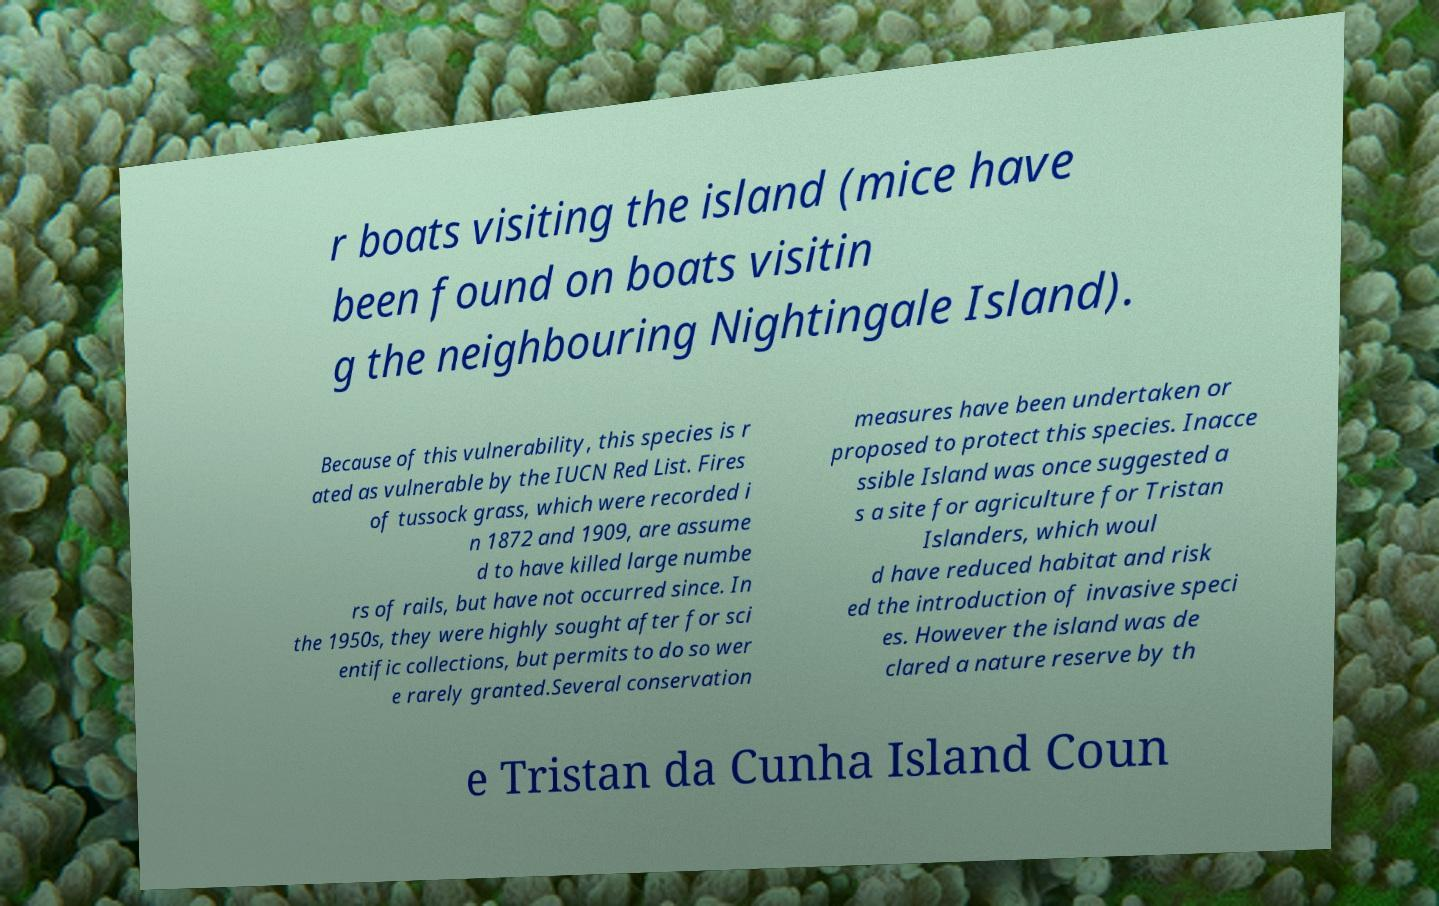Can you read and provide the text displayed in the image?This photo seems to have some interesting text. Can you extract and type it out for me? r boats visiting the island (mice have been found on boats visitin g the neighbouring Nightingale Island). Because of this vulnerability, this species is r ated as vulnerable by the IUCN Red List. Fires of tussock grass, which were recorded i n 1872 and 1909, are assume d to have killed large numbe rs of rails, but have not occurred since. In the 1950s, they were highly sought after for sci entific collections, but permits to do so wer e rarely granted.Several conservation measures have been undertaken or proposed to protect this species. Inacce ssible Island was once suggested a s a site for agriculture for Tristan Islanders, which woul d have reduced habitat and risk ed the introduction of invasive speci es. However the island was de clared a nature reserve by th e Tristan da Cunha Island Coun 